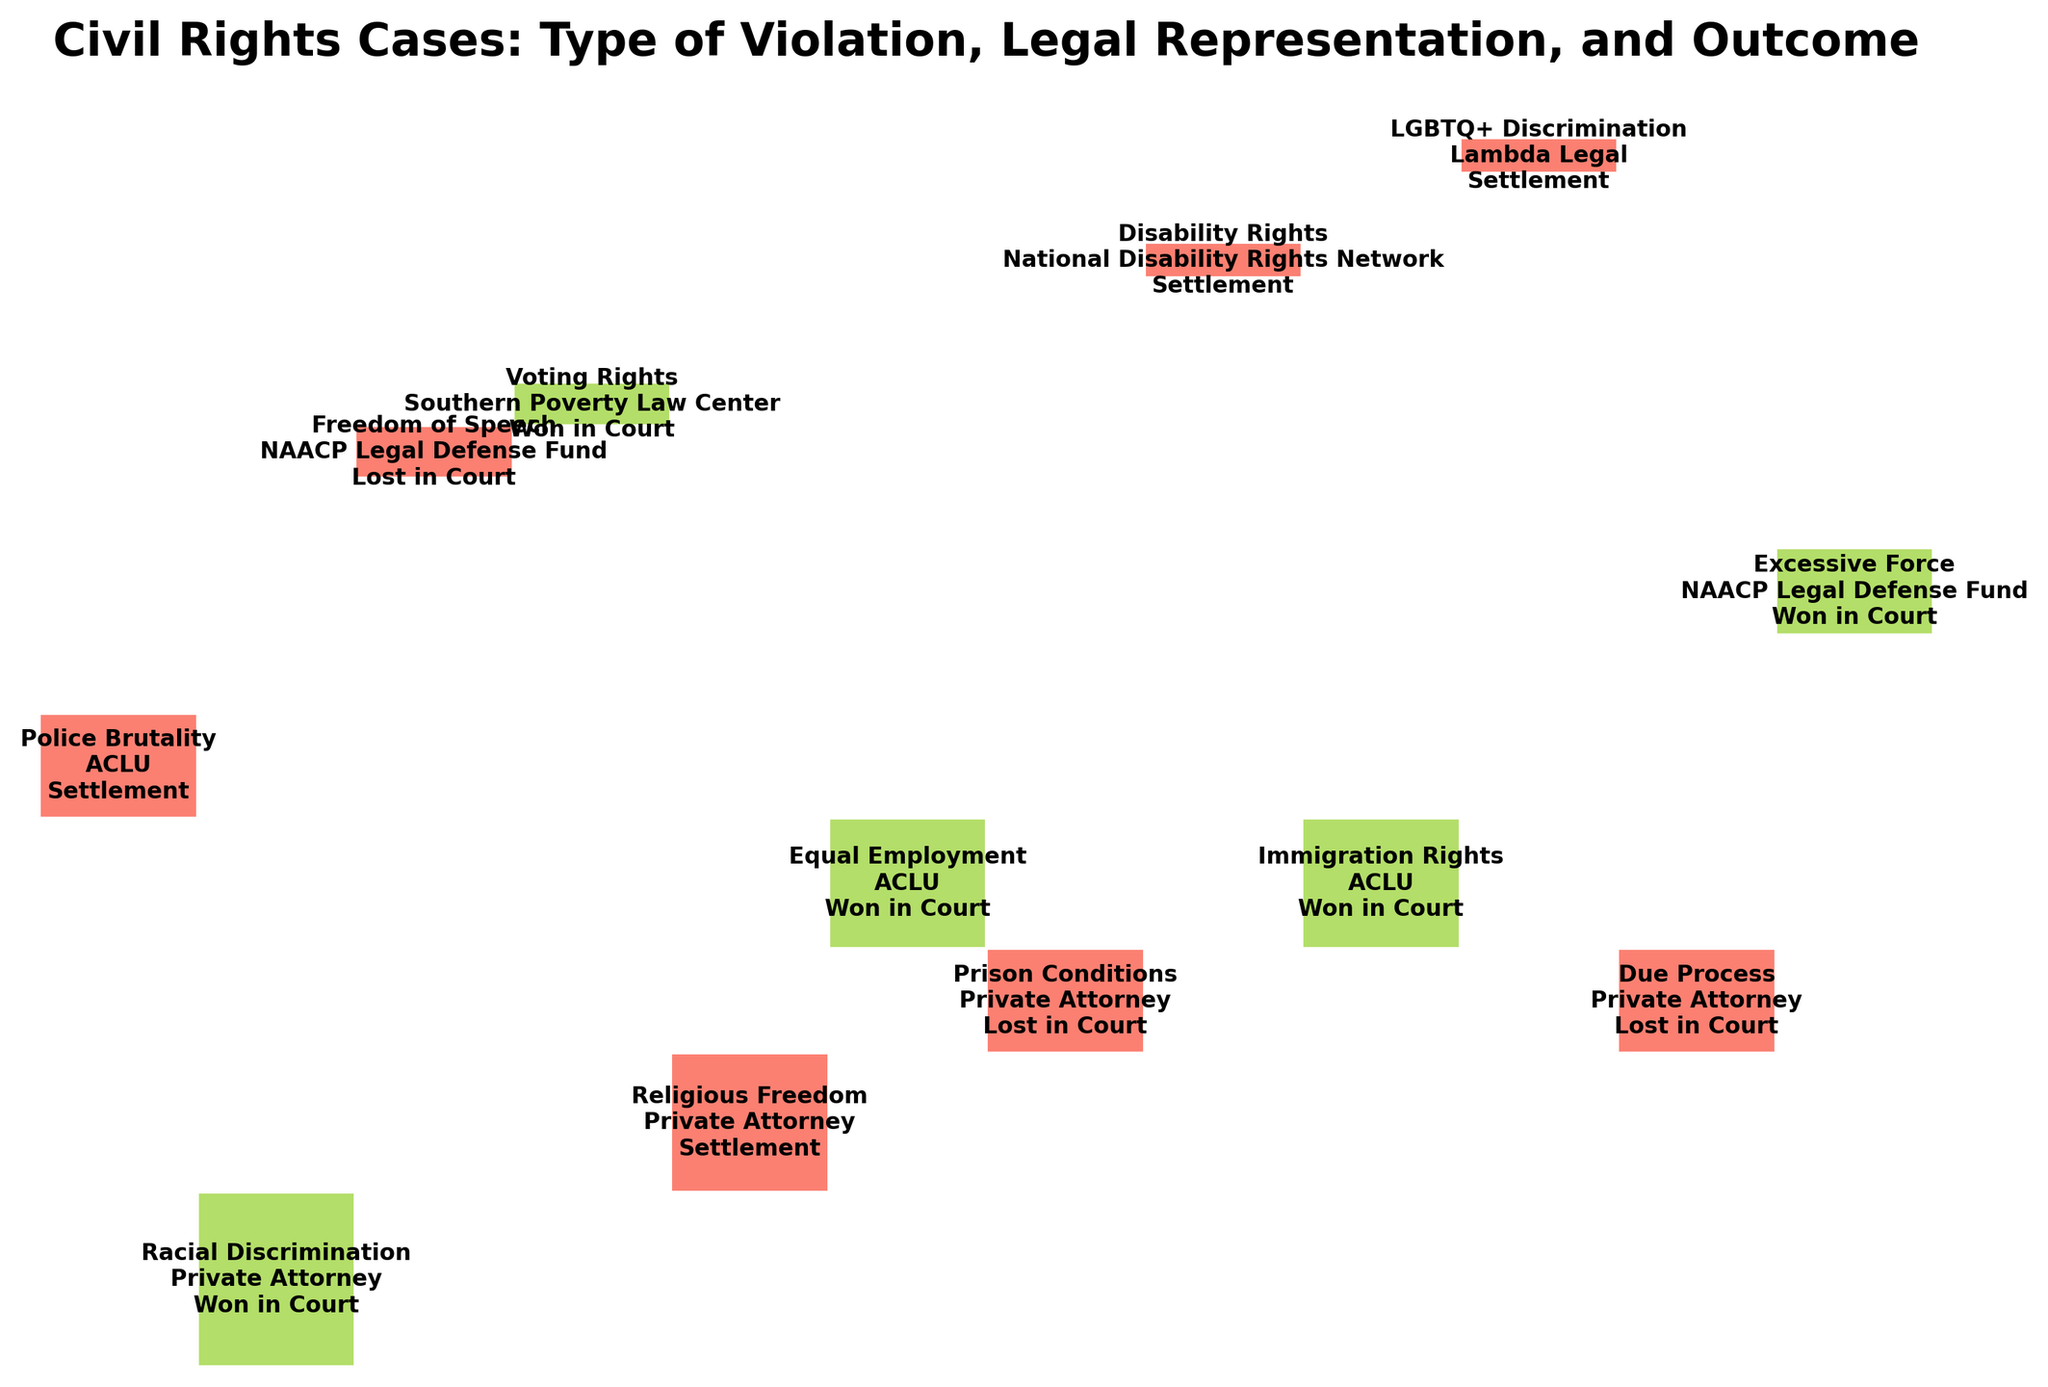What's the title of the figure? The title is written at the top of the figure.
Answer: Civil Rights Cases: Type of Violation, Legal Representation, and Outcome Which type of violation has the largest segment on the plot? To identify this, look for the largest horizontal segment in the figure.
Answer: Racial Discrimination How many cases were represented by the ACLU? Sum up the segments on the plot that mention ACLU as the legal representation.
Answer: 3 Which type of legal representation has the most successful (Won in Court) outcomes? Look for the vertical segments labeled "Won in Court" and identify which legal representation has the highest such segments.
Answer: Private Attorney Are there more settlements or court wins in the total data? Compare the total segments labeled "Settlement" versus those labeled "Won in Court" and "Lost in Court".
Answer: Settlement How many police brutality cases settled? Identify the part of the segment for Police Brutality that intersects with Settlement.
Answer: 1 Which legal representation handled Voting Rights cases and what was the outcome? Look for the Voting Rights segment and check its associated legal representation and outcome.
Answer: Southern Poverty Law Center, Won in Court Compare the number of cases involving NAACP Legal Defense Fund and Lambda Legal. Which has more? Identify and count the segments for NAACP Legal Defense Fund and Lambda Legal.
Answer: NAACP Legal Defense Fund What percentage of Private Attorney cases were lost in court? Identify the segments for Private Attorney by outcome, count the lost cases, and calculate the percentage.
Answer: 60% Are there any Religious Freedom cases represented by the ACLU? Check the Religious Freedom segment for any intersection with the ACLU.
Answer: No 